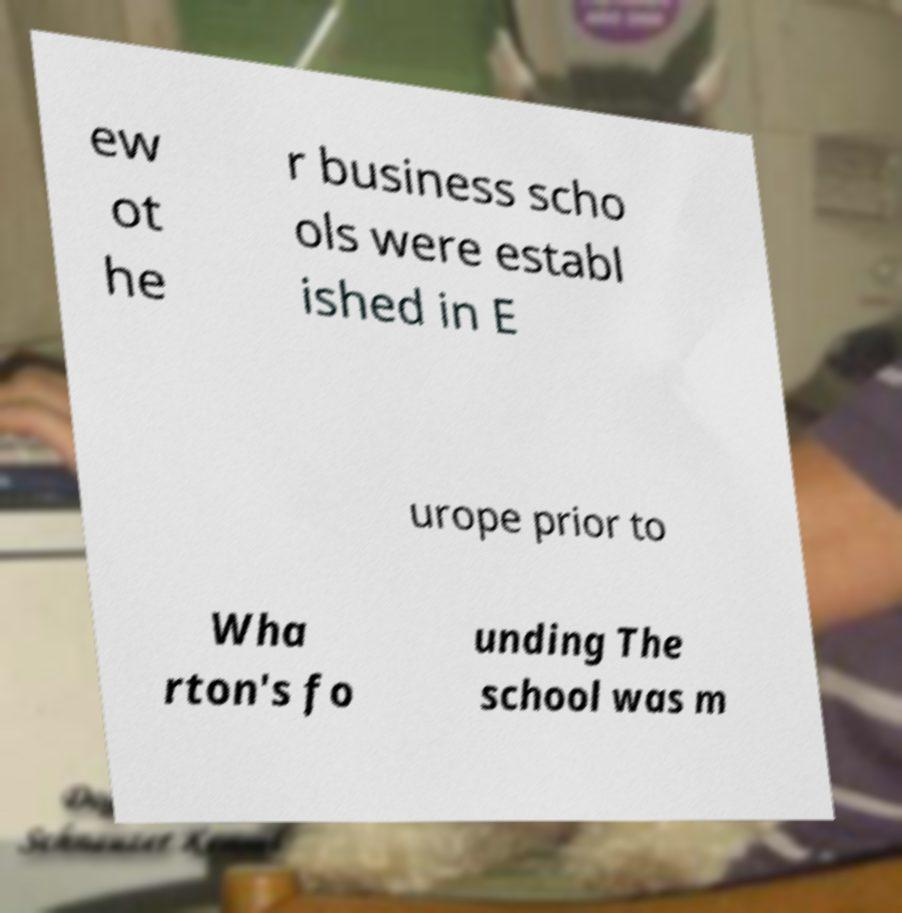Could you assist in decoding the text presented in this image and type it out clearly? ew ot he r business scho ols were establ ished in E urope prior to Wha rton's fo unding The school was m 